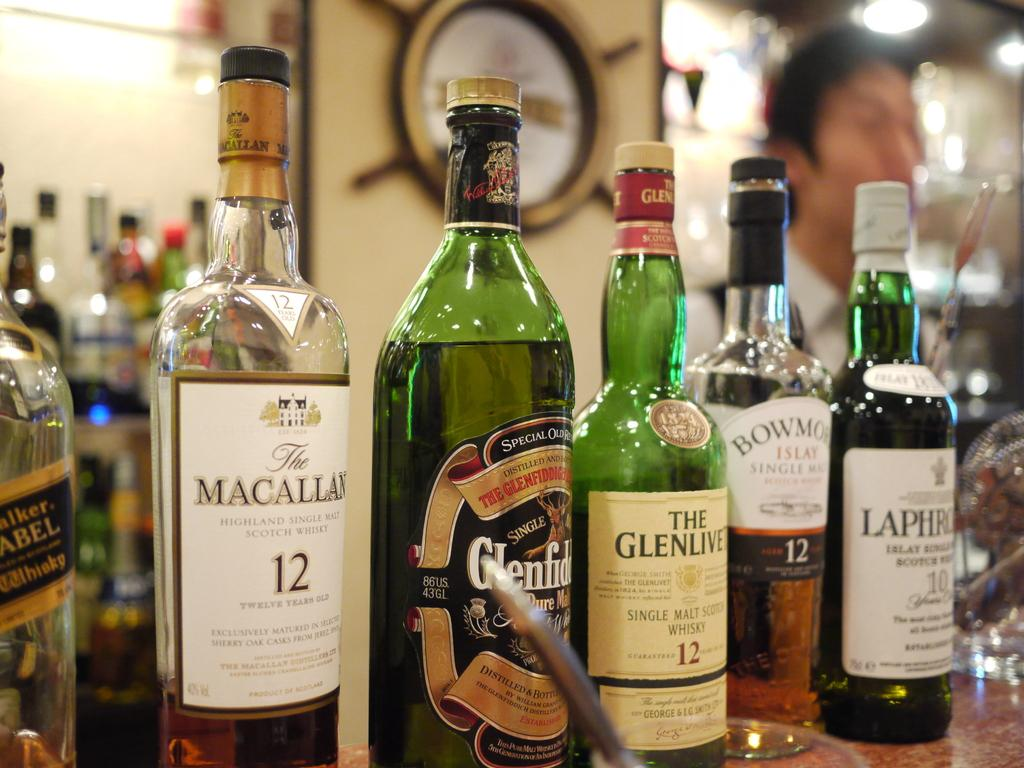<image>
Describe the image concisely. Bottles of alcohol sit displayed with one saying Islay on it. 